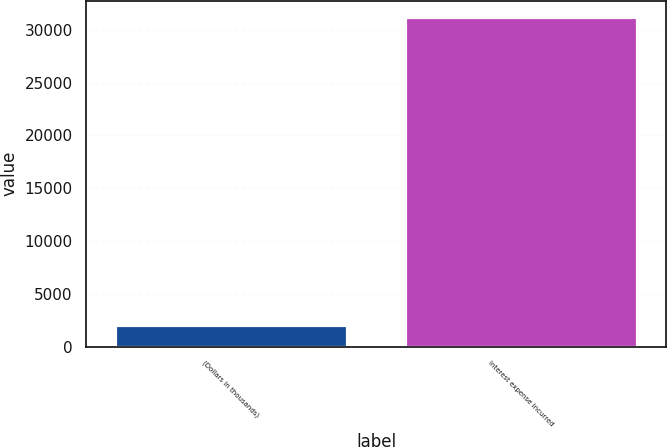<chart> <loc_0><loc_0><loc_500><loc_500><bar_chart><fcel>(Dollars in thousands)<fcel>Interest expense incurred<nl><fcel>2009<fcel>31190<nl></chart> 